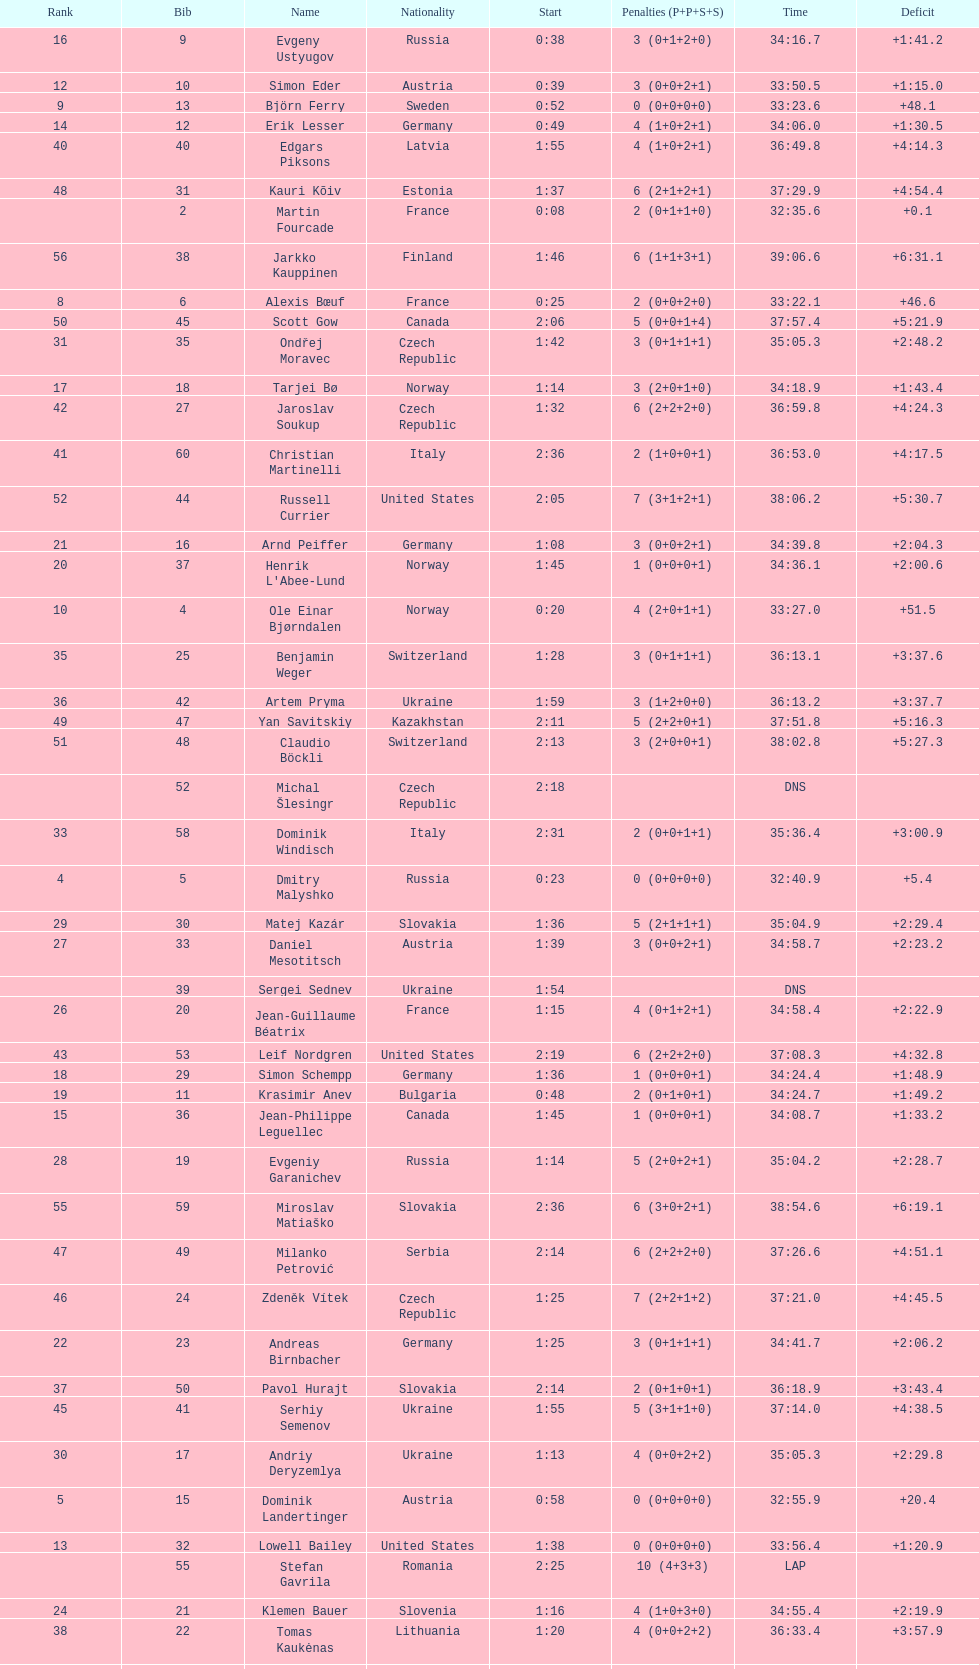How many united states competitors did not win medals? 4. 